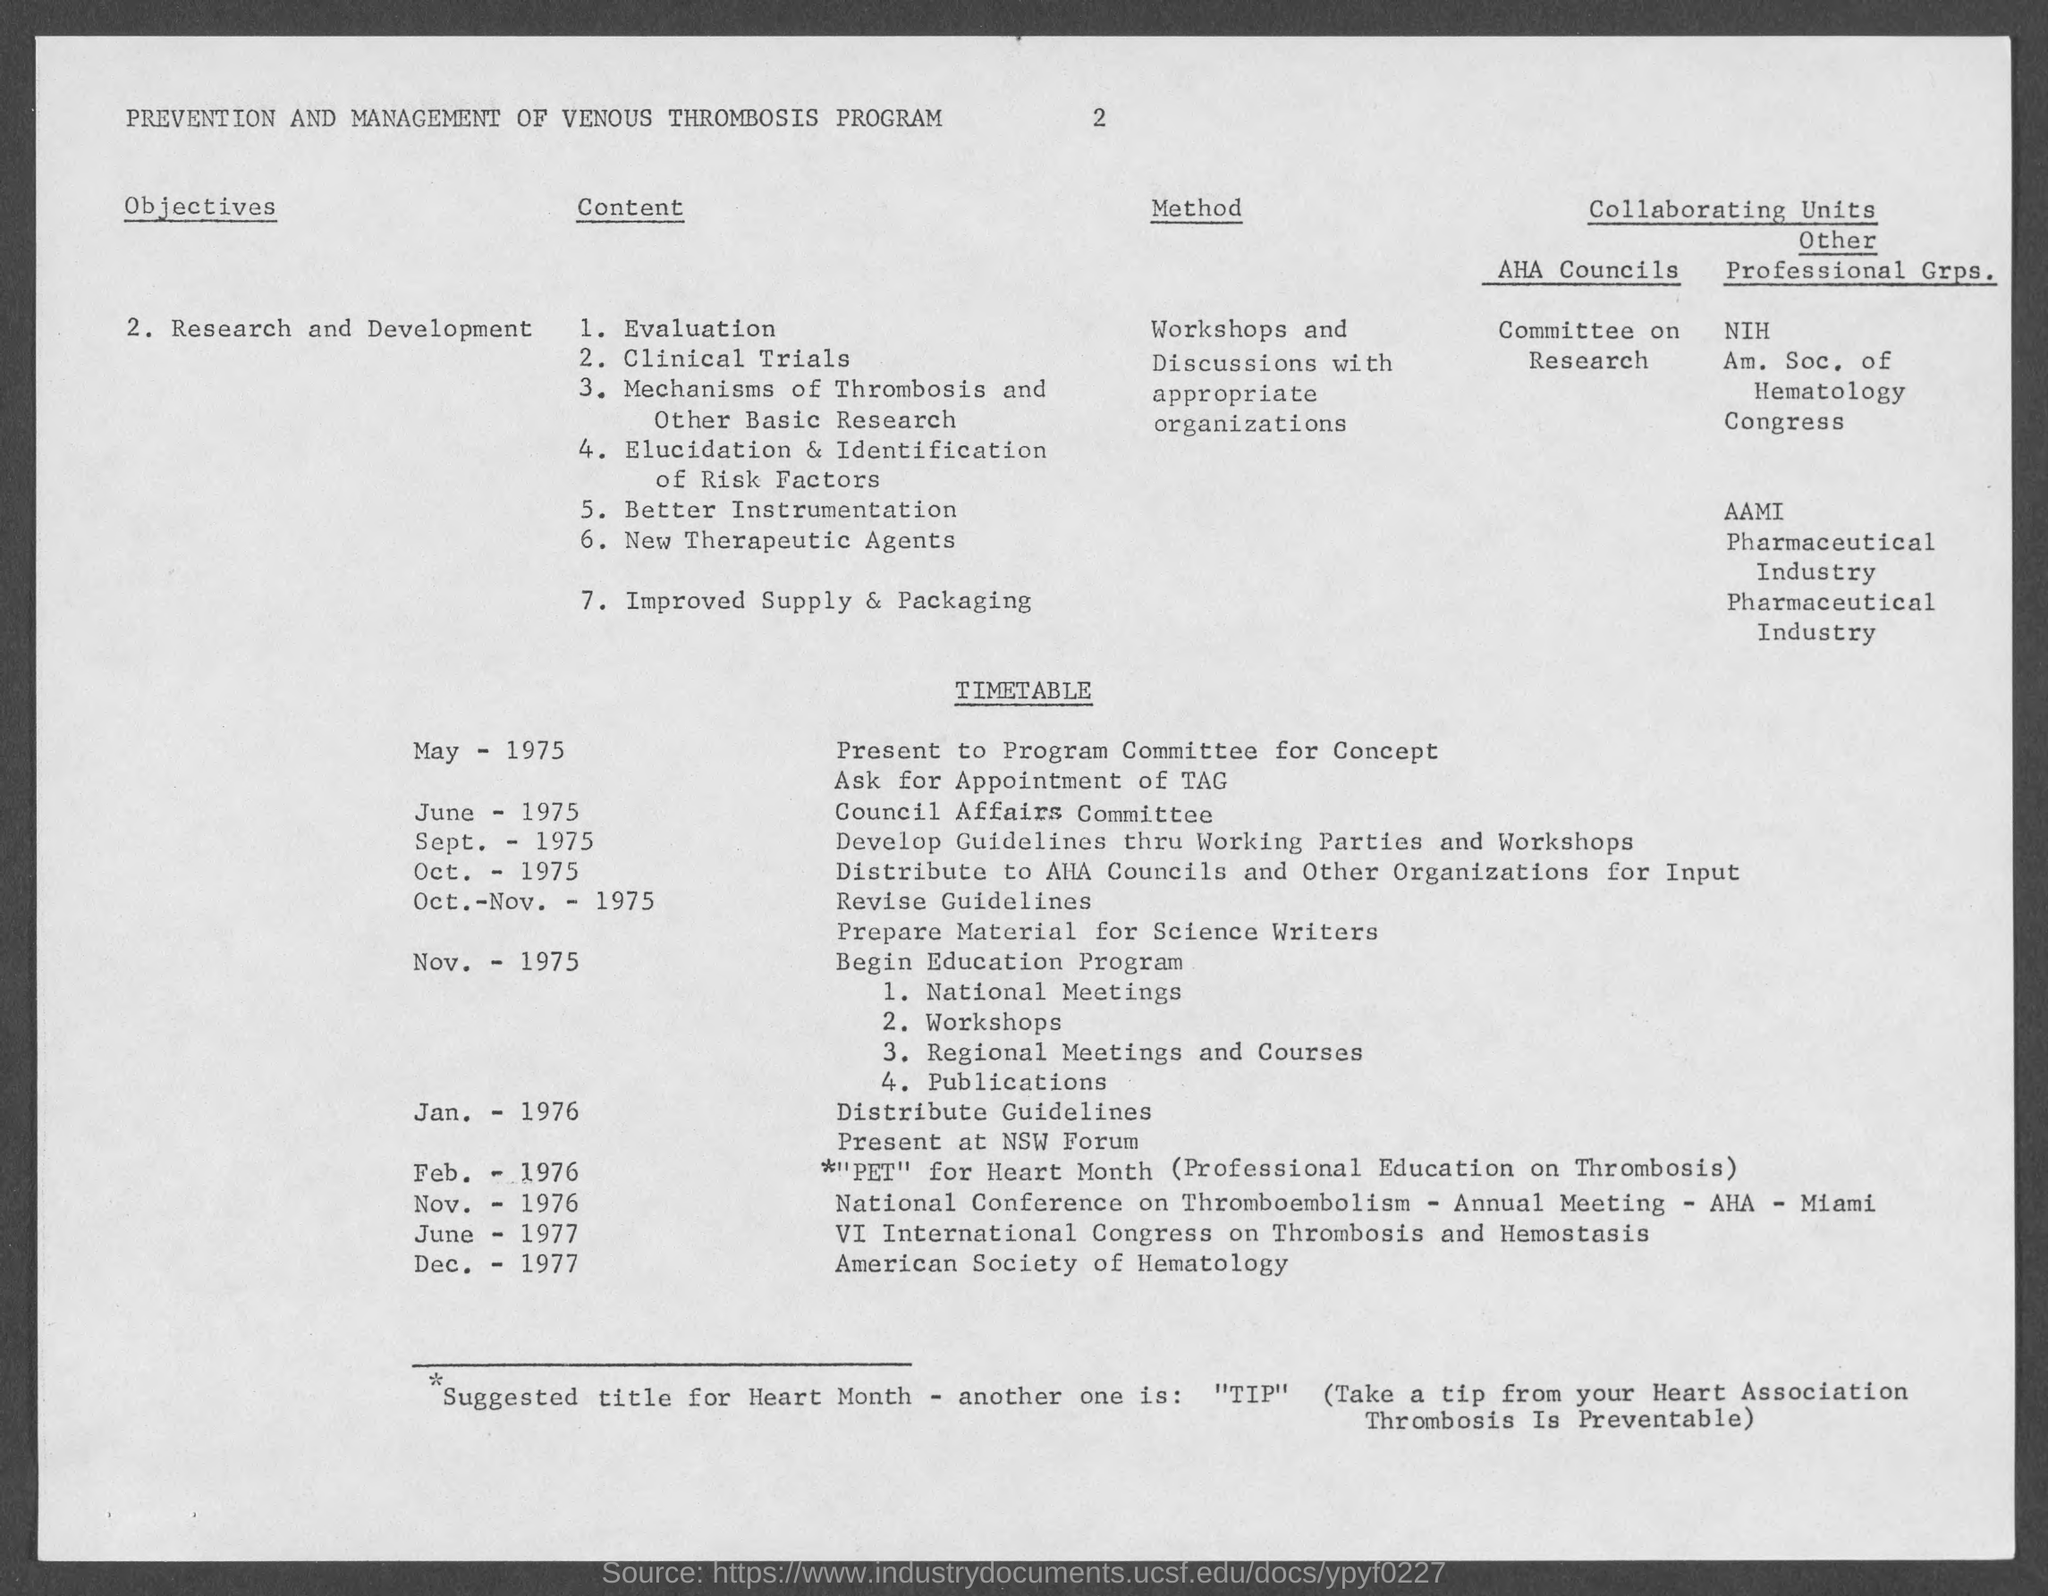What is the page number?
Provide a short and direct response. 2. What is the title of the document?
Your answer should be compact. Prevention and Management of Venous Thrombosis Program. 